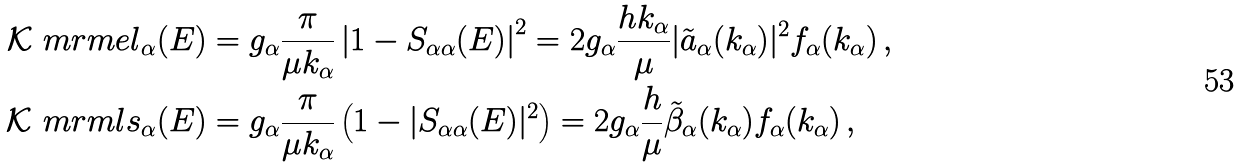<formula> <loc_0><loc_0><loc_500><loc_500>\mathcal { K } ^ { \ } m r m { e l } _ { \alpha } ( E ) & = g _ { \alpha } \frac { \pi } { \mu k _ { \alpha } } \left | 1 - S _ { \alpha \alpha } ( E ) \right | ^ { 2 } = 2 g _ { \alpha } \frac { h k _ { \alpha } } { \mu } | \tilde { a } _ { \alpha } ( k _ { \alpha } ) | ^ { 2 } f _ { \alpha } ( k _ { \alpha } ) \, , \\ \mathcal { K } ^ { \ } m r m { l s } _ { \alpha } ( E ) & = g _ { \alpha } \frac { \pi } { \mu k _ { \alpha } } \left ( 1 - | S _ { \alpha \alpha } ( E ) | ^ { 2 } \right ) = 2 g _ { \alpha } \frac { h } { \mu } \tilde { \beta } _ { \alpha } ( k _ { \alpha } ) f _ { \alpha } ( k _ { \alpha } ) \, ,</formula> 